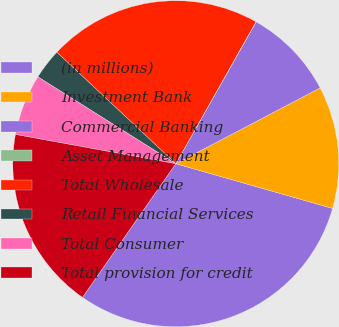Convert chart. <chart><loc_0><loc_0><loc_500><loc_500><pie_chart><fcel>(in millions)<fcel>Investment Bank<fcel>Commercial Banking<fcel>Asset Management<fcel>Total Wholesale<fcel>Retail Financial Services<fcel>Total Consumer<fcel>Total provision for credit<nl><fcel>30.28%<fcel>12.12%<fcel>9.1%<fcel>0.02%<fcel>21.2%<fcel>3.04%<fcel>6.07%<fcel>18.17%<nl></chart> 